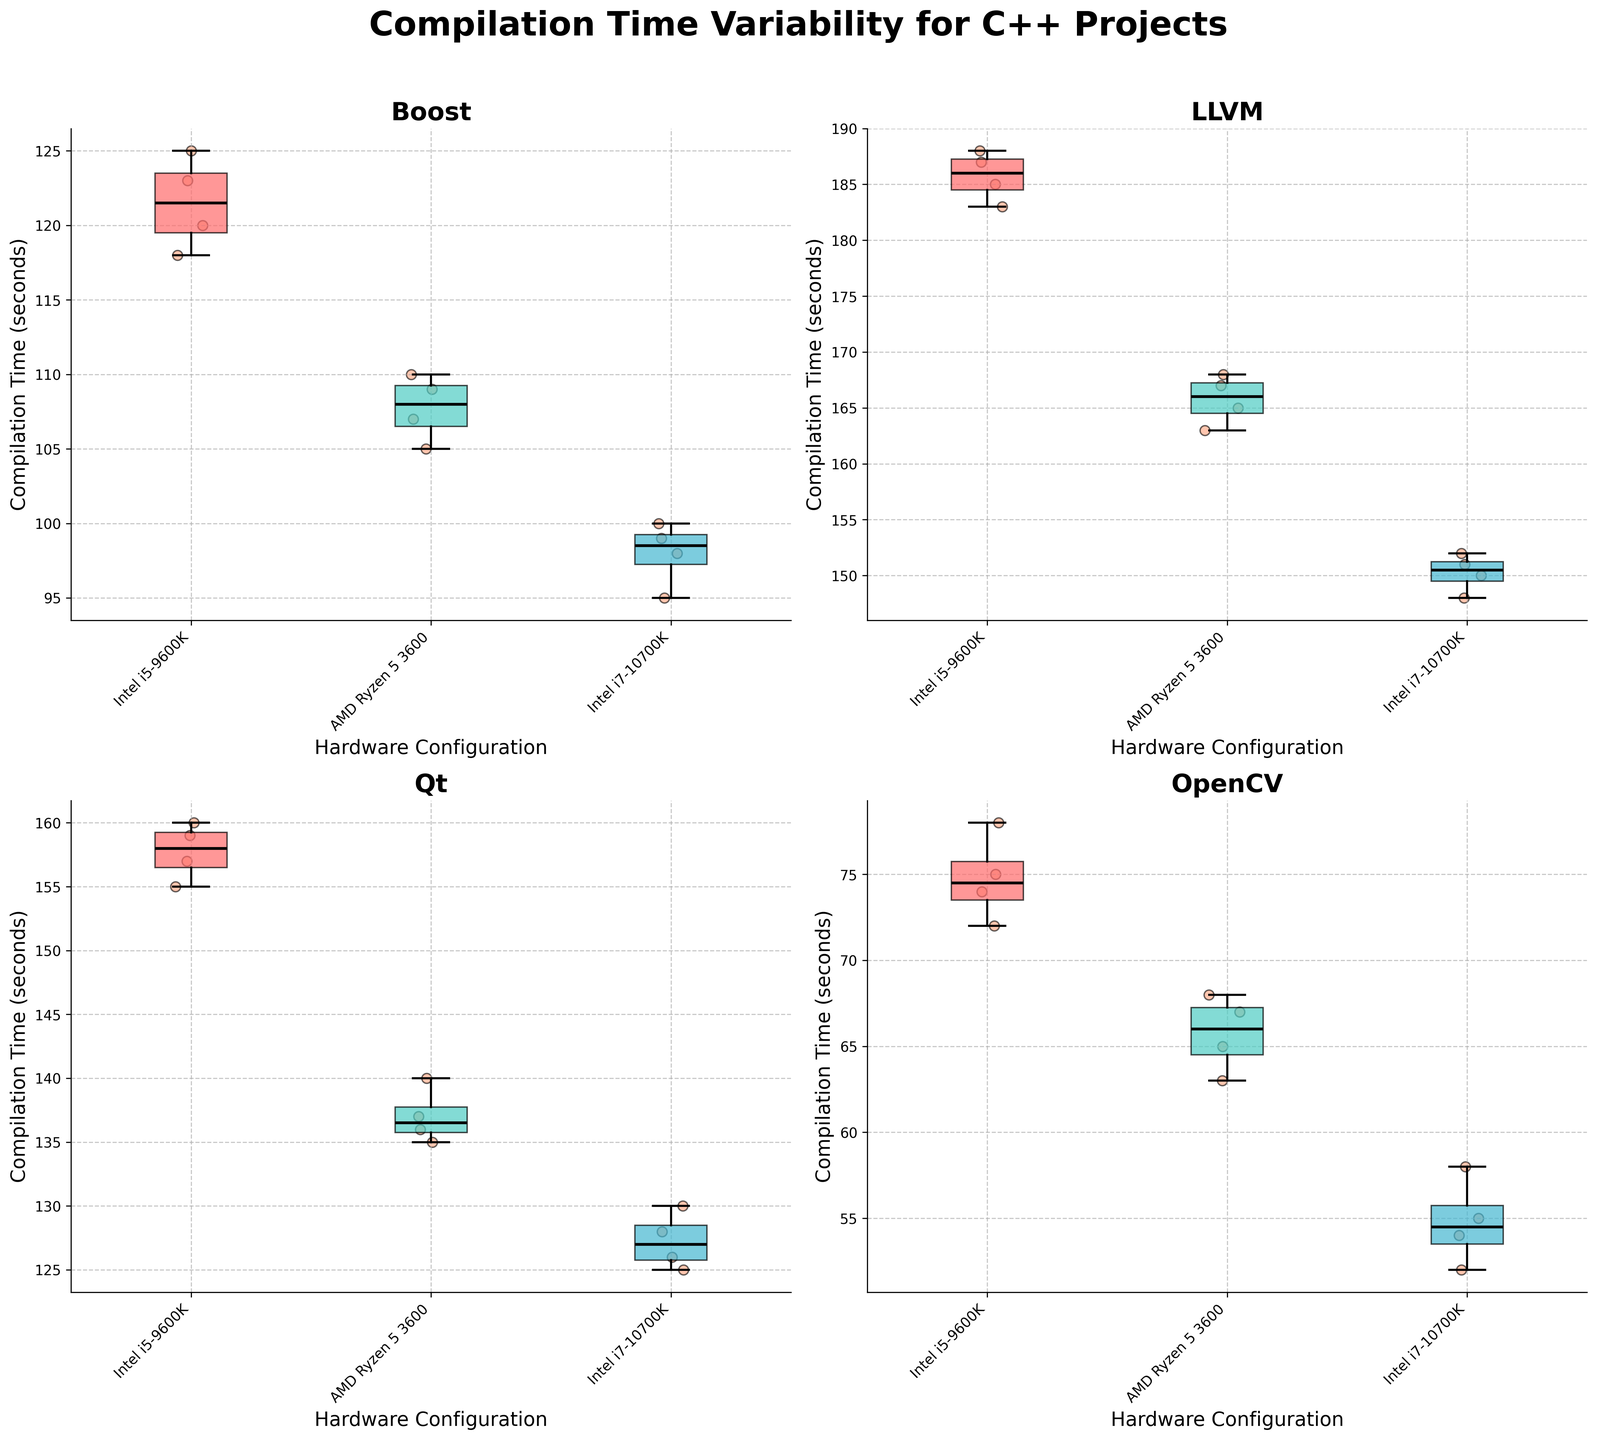What's the title of the figure? The title is displayed at the top center of the figure. It reads "Compilation Time Variability for C++ Projects".
Answer: Compilation Time Variability for C++ Projects What are the hardware configurations listed on the x-axis for each subplot? Each subplot has hardware configurations listed on the x-axis, which can be seen under each box plot. The configurations are "Intel i5-9600K", "AMD Ryzen 5 3600", and "Intel i7-10700K".
Answer: Intel i5-9600K, AMD Ryzen 5 3600, Intel i7-10700K Which project has the lowest median compilation time? The median compilation time is represented by the bold horizontal line inside each box plot. For "OpenCV", the Intel i7-10700K configuration has the lowest median line.
Answer: OpenCV What is the interquartile range (IQR) for Boost on AMD Ryzen 5 3600? The IQR is the range between the first quartile (bottom of the box) and the third quartile (top of the box). For "Boost" on "AMD Ryzen 5 3600", the first quartile is around 105 seconds, and the third quartile is around 110 seconds. The IQR is 110 - 105.
Answer: 5 seconds Which project has the most consistent compilation times across all hardware configurations? Consistency can be assessed by looking at the length of the whiskers and the spread of the data points. "Boost" shows relatively short whiskers and tight clustering of data points across all configurations.
Answer: Boost How does the median compilation time for LLVM on Intel i5-9600K compare to Intel i7-10700K? Compare the bold horizontal lines in the box plots of LLVM for the two hardware configurations. The median time is higher for the Intel i5-9600K than for the Intel i7-10700K.
Answer: Higher on Intel i5-9600K Which hardware configuration has the highest compilation time for Qt? Check the topmost point of each box plot for "Qt". The Intel i5-9600K configuration shows the highest top end of the box plot.
Answer: Intel i5-9600K What's the general trend of compilation times from Intel i5-9600K to AMD Ryzen 5 3600 to Intel i7-10700K for any project? Observe the box plots for each project across the three hardware configurations. Most projects show a downward trend, indicating faster compilation times as we move from Intel i5-9600K to AMD Ryzen 5 3600 to Intel i7-10700K.
Answer: Downward trend Are there any outliers in the data, and if so, for which project and hardware configuration? Outliers are represented by individual data points that lie outside the whiskers in the box plots. There don't appear to be any outliers as no points are plotted beyond the whiskers.
Answer: No outliers Describe the spread of compilation times for OpenCV on AMD Ryzen 5 3600. The spread can be understood by looking at the length of the box and the whiskers. The box is small, with whiskers extending slightly, indicating tight clustering around the median and low variability.
Answer: Tight clustering, low variability 